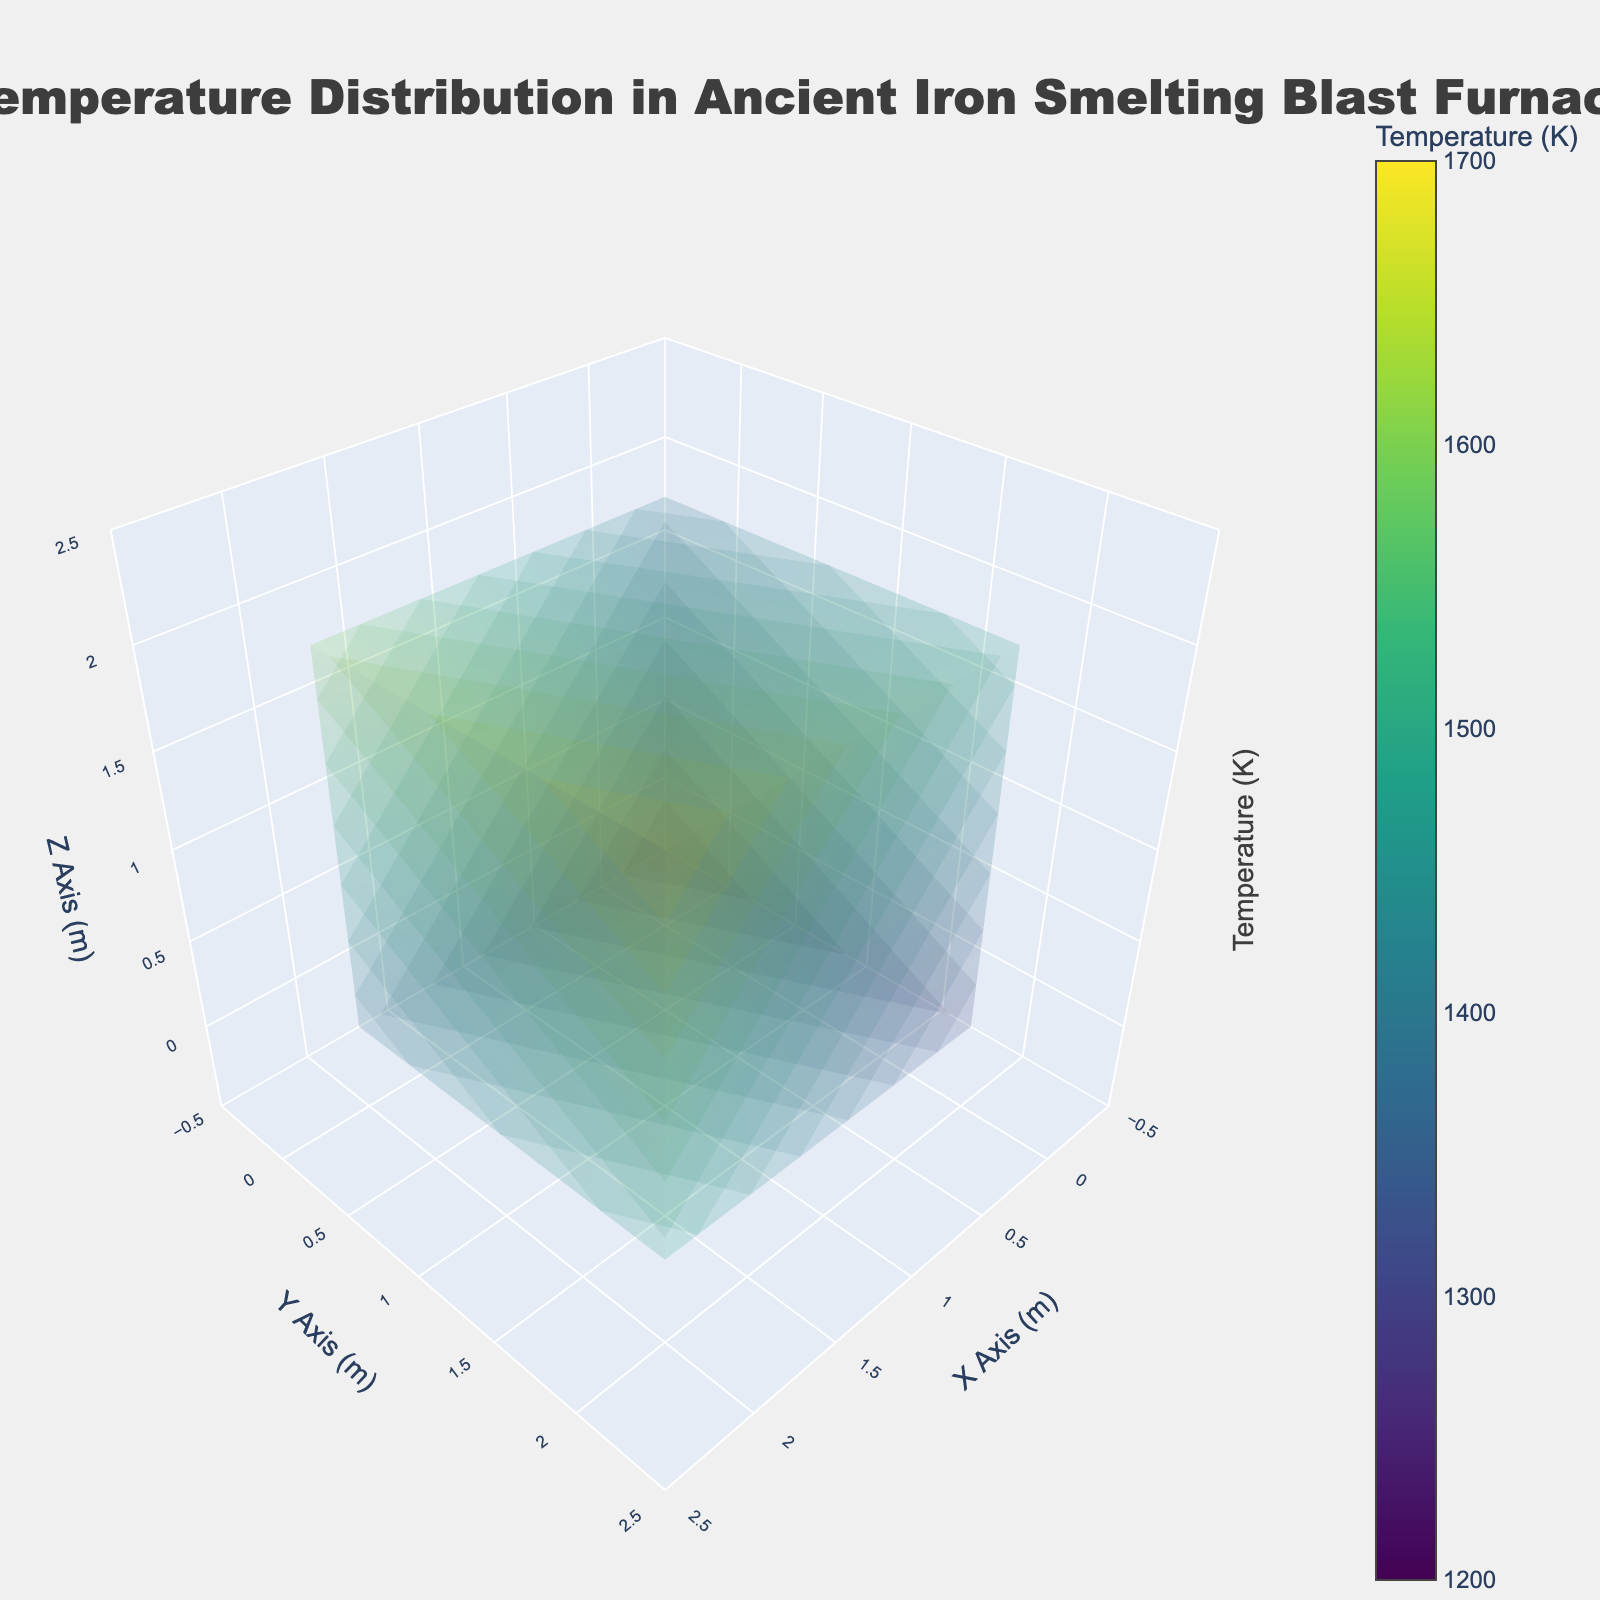What is the title of the plot? The title is displayed prominently at the top of the figure and reads 'Temperature Distribution in Ancient Iron Smelting Blast Furnace'.
Answer: Temperature Distribution in Ancient Iron Smelting Blast Furnace What is the range of the temperature values displayed in the plot? The temperature values range from 1200 to 1700, as indicated by the isomin and isomax settings in the color scale.
Answer: 1200 to 1700 How many unique temperature levels are visualized in the plot? The plot incorporates 17 surface levels to represent different temperature ranges within the blast furnace.
Answer: 17 What axis labels are used in the 3D plot? The x, y, and z axes are labeled as 'X Axis (m)', 'Y Axis (m)', and 'Z Axis (m)' respectively.
Answer: X Axis (m), Y Axis (m), Z Axis (m) Which coordinates (x, y, z) show the highest temperature, and what is the value? By examining the plotted points, it is observed that the highest temperature occurs at coordinates (2, 2, 2) with a value of 1700 K.
Answer: (2, 2, 2), 1700 K What is the average temperature at (x=1) plane? To find the average, sum temperatures at x=1: (1300 + 1400 + 1500 + 1350 + 1450 + 1550 + 1400 + 1500 + 1600) which totals 13050. Divide by 9 (data points): 13050 / 9 = 1450 K.
Answer: 1450 K How does the temperature change as you move along the z-axis at (x=2, y=1)? At coordinates (x=2, y=1), the temperatures along the z-axis are 1450 K, 1550 K, and 1650 K, indicating an increasing trend.
Answer: Increasing Which slice of the blast furnace, based on y-axis planes, displays the highest average temperature? Calculate the average temperature for each y-axis plane:  
- y=0: (1200 + 1300 + 1400 + 1300 + 1400 + 1500 + 1400 + 1500 + 1600) / 9 = 1400 K  
- y=1: (1250 + 1350 + 1450 + 1350 + 1450 + 1550 + 1450 + 1550 + 1650) / 9 = 1461.11 K  
- y=2: (1300 + 1400 + 1500 + 1400 + 1500 + 1600 + 1500 + 1600 + 1700) / 9 = 1500 K  
y=2 plane displays the highest average temperature.
Answer: y=2 